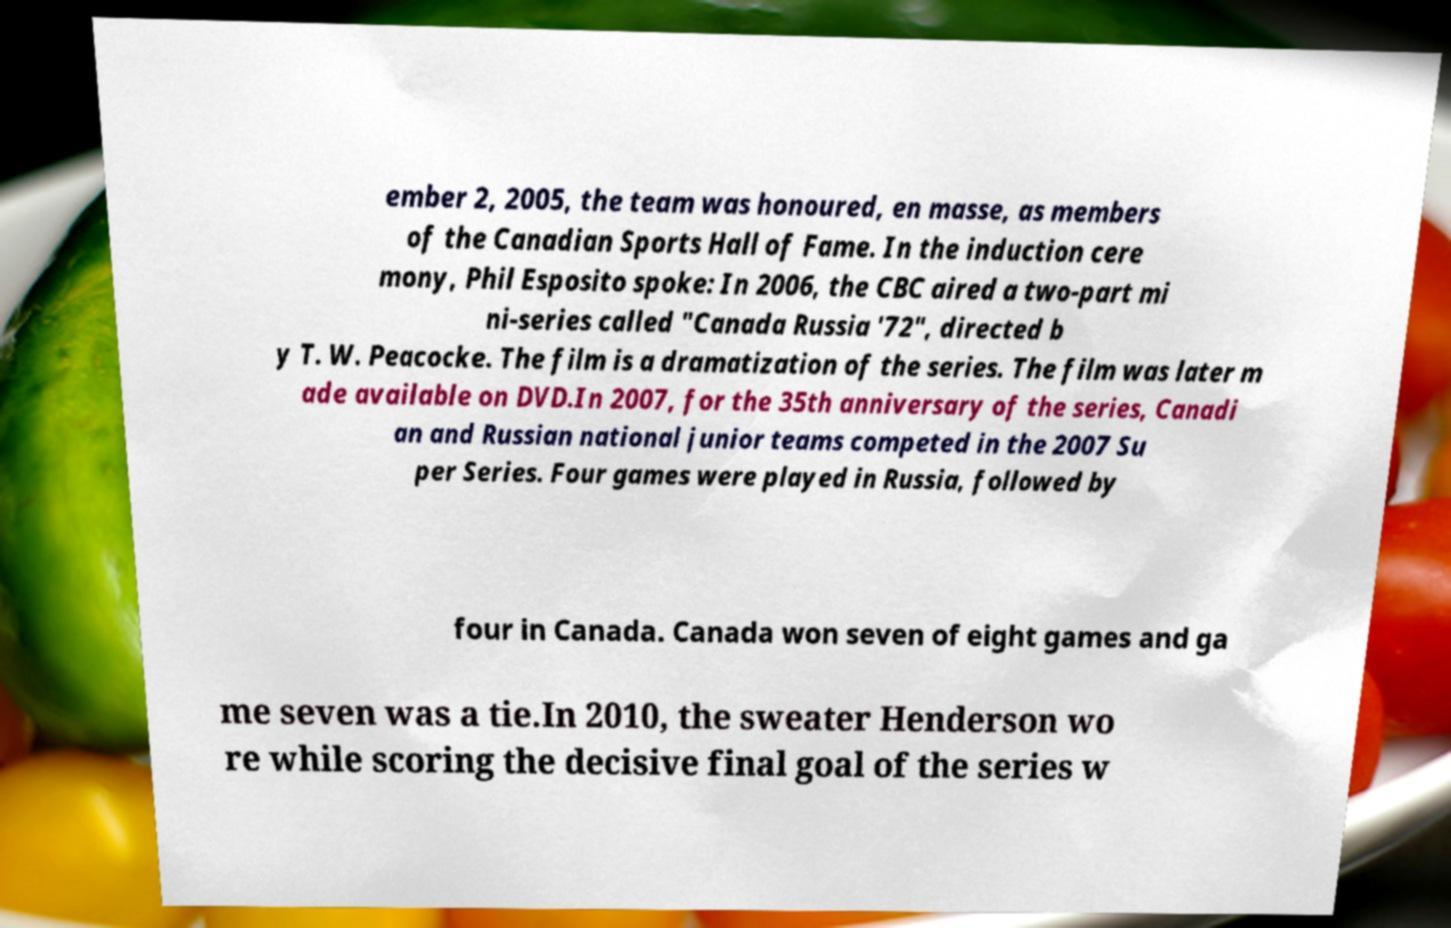There's text embedded in this image that I need extracted. Can you transcribe it verbatim? ember 2, 2005, the team was honoured, en masse, as members of the Canadian Sports Hall of Fame. In the induction cere mony, Phil Esposito spoke: In 2006, the CBC aired a two-part mi ni-series called "Canada Russia '72", directed b y T. W. Peacocke. The film is a dramatization of the series. The film was later m ade available on DVD.In 2007, for the 35th anniversary of the series, Canadi an and Russian national junior teams competed in the 2007 Su per Series. Four games were played in Russia, followed by four in Canada. Canada won seven of eight games and ga me seven was a tie.In 2010, the sweater Henderson wo re while scoring the decisive final goal of the series w 